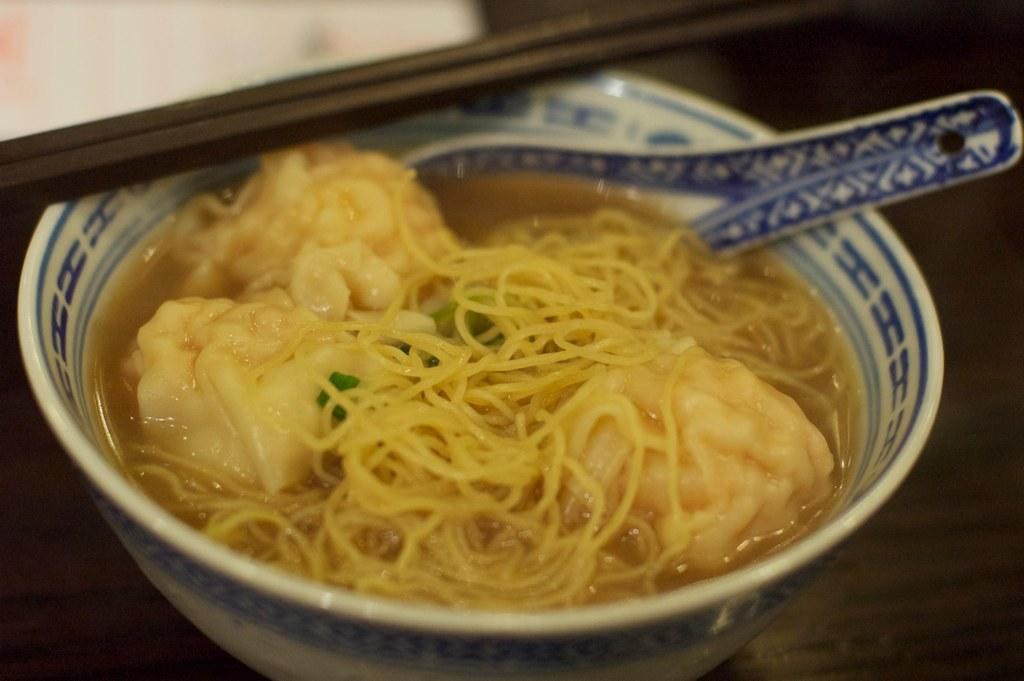What is in the cup that is visible in the image? There is a food item in a cup. Where is the cup located in the image? The cup is placed on a table. What type of crack can be seen on the man's face in the image? There is no man present in the image, and therefore no crack on a man's face can be observed. Is there a chicken visible in the image? No, there is no chicken present in the image. 